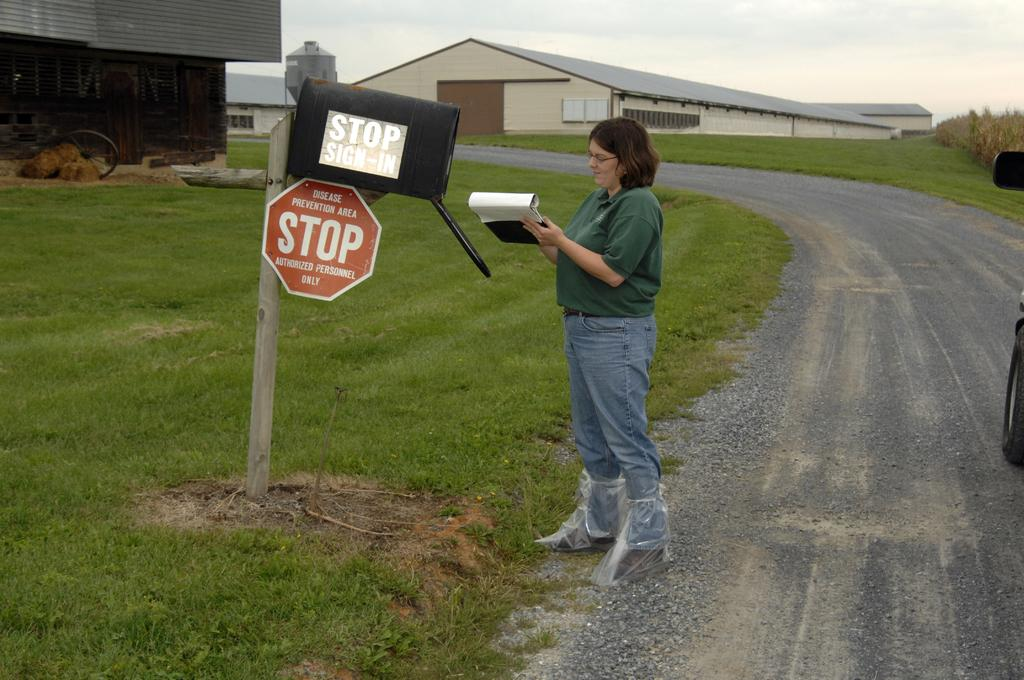<image>
Give a short and clear explanation of the subsequent image. a person standing next to a stop sign 